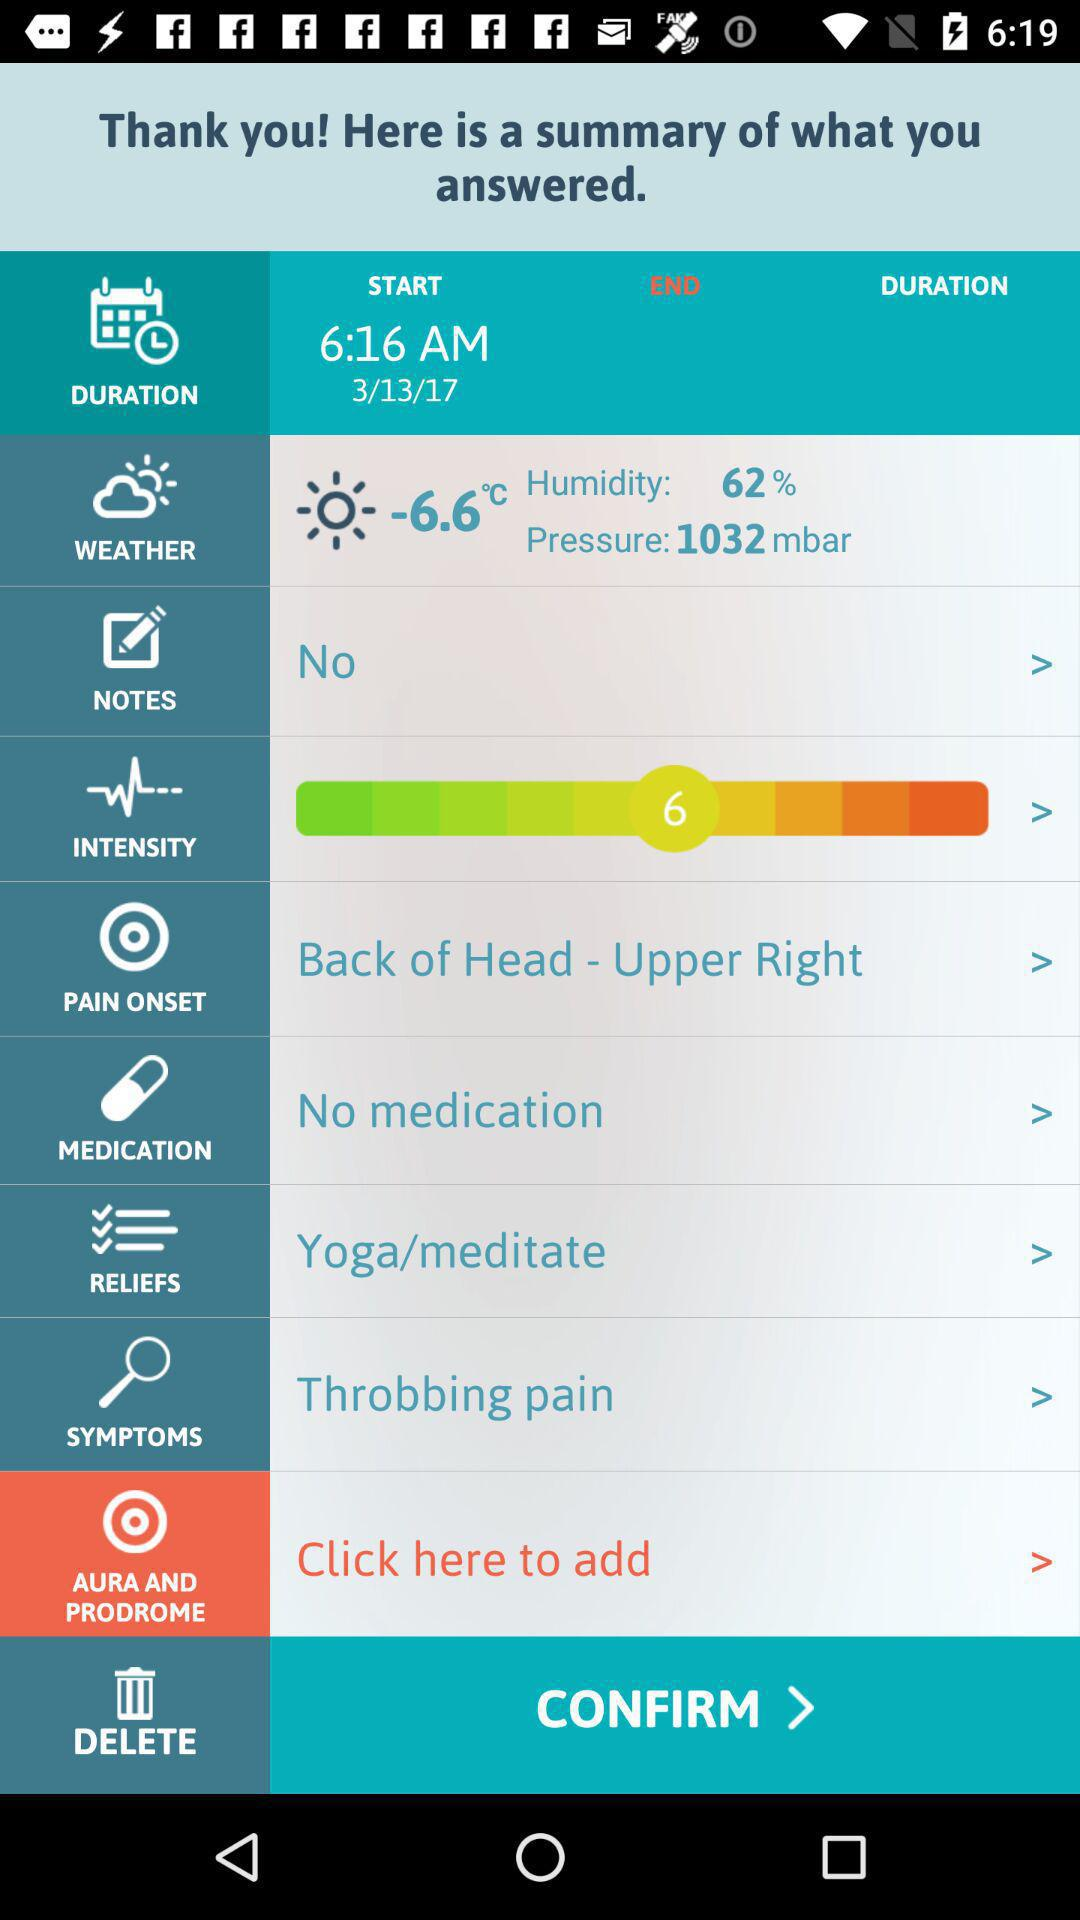What is the temperature? The temperature is -6.6 °C. 